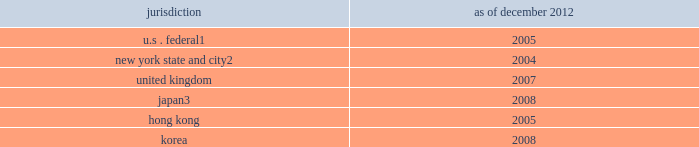Notes to consolidated financial statements regulatory tax examinations the firm is subject to examination by the u.s .
Internal revenue service ( irs ) and other taxing authorities in jurisdictions where the firm has significant business operations , such as the united kingdom , japan , hong kong , korea and various states , such as new york .
The tax years under examination vary by jurisdiction .
The firm believes that during 2013 , certain audits have a reasonable possibility of being completed .
The firm does not expect completion of these audits to have a material impact on the firm 2019s financial condition but it may be material to operating results for a particular period , depending , in part , on the operating results for that period .
The table below presents the earliest tax years that remain subject to examination by major jurisdiction .
Jurisdiction december 2012 u.s .
Federal 1 2005 new york state and city 2 2004 .
Irs examination of fiscal 2008 through calendar 2010 began during 2011 .
Irs examination of fiscal 2005 , 2006 and 2007 began during 2008 .
Irs examination of fiscal 2003 and 2004 has been completed , but the liabilities for those years are not yet final .
The firm anticipates that the audits of fiscal 2005 through calendar 2010 should be completed during 2013 , and the audits of 2011 through 2012 should begin in 2013 .
New york state and city examination of fiscal 2004 , 2005 and 2006 began in 2008 .
Japan national tax agency examination of fiscal 2005 through 2009 began in 2010 .
The examinations have been completed , but the liabilities for 2008 and 2009 are not yet final .
All years subsequent to the above remain open to examination by the taxing authorities .
The firm believes that the liability for unrecognized tax benefits it has established is adequate in relation to the potential for additional assessments .
In january 2013 , the firm was accepted into the compliance assurance process program by the irs .
This program will allow the firm to work with the irs to identify and resolve potential u.s .
Federal tax issues before the filing of tax returns .
The 2013 tax year will be the first year examined under the program .
Note 25 .
Business segments the firm reports its activities in the following four business segments : investment banking , institutional client services , investing & lending and investment management .
Basis of presentation in reporting segments , certain of the firm 2019s business lines have been aggregated where they have similar economic characteristics and are similar in each of the following areas : ( i ) the nature of the services they provide , ( ii ) their methods of distribution , ( iii ) the types of clients they serve and ( iv ) the regulatory environments in which they operate .
The cost drivers of the firm taken as a whole 2014 compensation , headcount and levels of business activity 2014 are broadly similar in each of the firm 2019s business segments .
Compensation and benefits expenses in the firm 2019s segments reflect , among other factors , the overall performance of the firm as well as the performance of individual businesses .
Consequently , pre-tax margins in one segment of the firm 2019s business may be significantly affected by the performance of the firm 2019s other business segments .
The firm allocates assets ( including allocations of excess liquidity and cash , secured client financing and other assets ) , revenues and expenses among the four reportable business segments .
Due to the integrated nature of these segments , estimates and judgments are made in allocating certain assets , revenues and expenses .
Transactions between segments are based on specific criteria or approximate third-party rates .
Total operating expenses include corporate items that have not been allocated to individual business segments .
The allocation process is based on the manner in which management currently views the performance of the segments .
Goldman sachs 2012 annual report 195 .
How many years longer is the u.s . federal exam than the new york state and city exam? 
Computations: (2005 - 2004)
Answer: 1.0. 